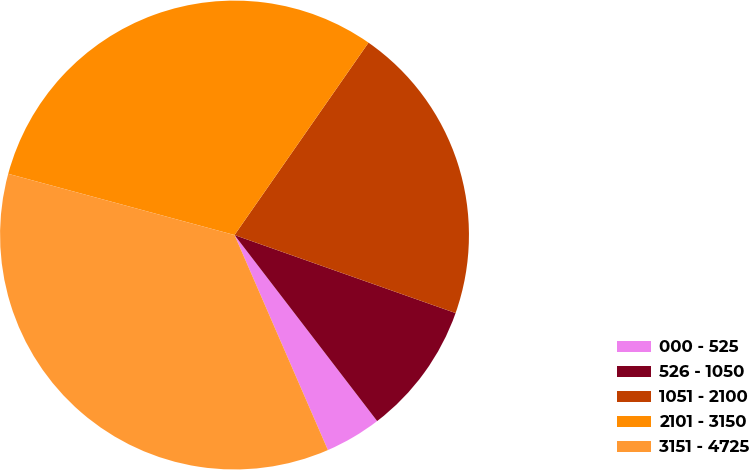Convert chart to OTSL. <chart><loc_0><loc_0><loc_500><loc_500><pie_chart><fcel>000 - 525<fcel>526 - 1050<fcel>1051 - 2100<fcel>2101 - 3150<fcel>3151 - 4725<nl><fcel>3.89%<fcel>9.19%<fcel>20.72%<fcel>30.48%<fcel>35.73%<nl></chart> 